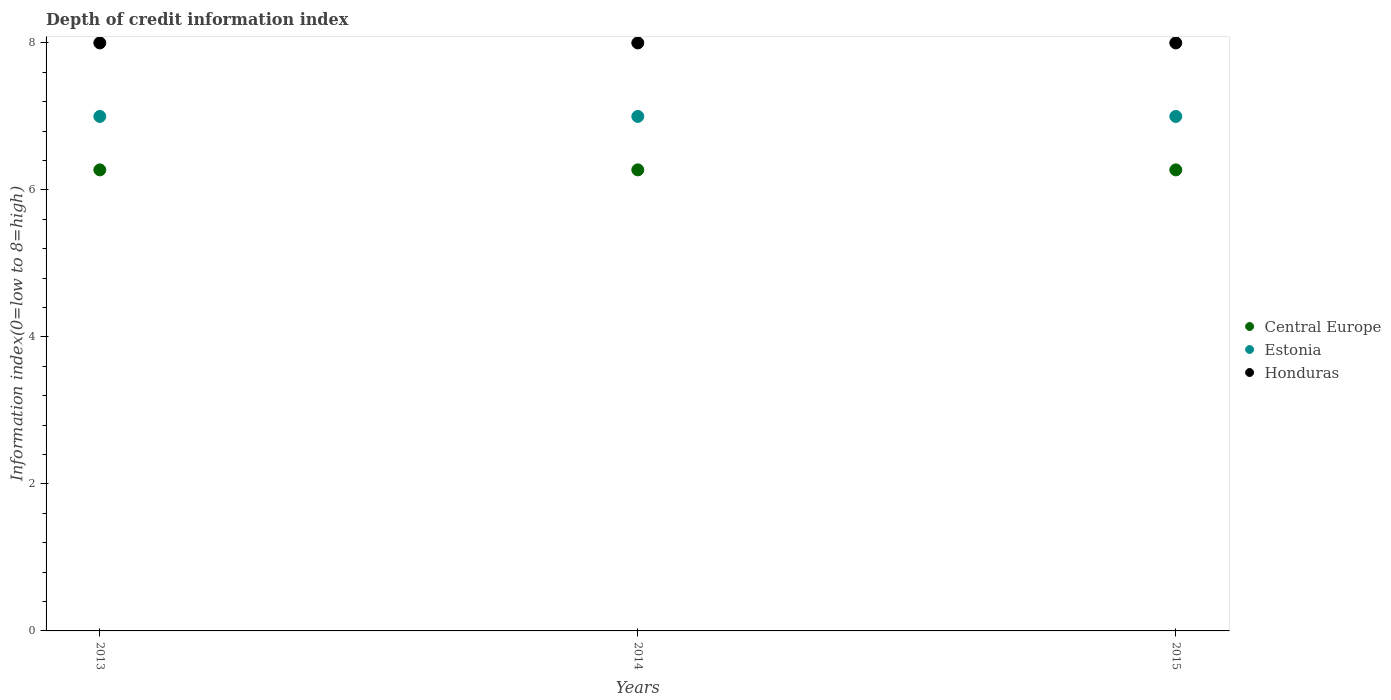How many different coloured dotlines are there?
Provide a succinct answer. 3. What is the information index in Central Europe in 2013?
Make the answer very short. 6.27. Across all years, what is the maximum information index in Estonia?
Make the answer very short. 7. Across all years, what is the minimum information index in Honduras?
Provide a succinct answer. 8. What is the total information index in Honduras in the graph?
Offer a terse response. 24. What is the difference between the information index in Honduras in 2013 and that in 2015?
Provide a succinct answer. 0. What is the difference between the information index in Estonia in 2013 and the information index in Central Europe in 2014?
Offer a very short reply. 0.73. In the year 2013, what is the difference between the information index in Estonia and information index in Honduras?
Provide a succinct answer. -1. What is the ratio of the information index in Estonia in 2013 to that in 2015?
Make the answer very short. 1. Is the difference between the information index in Estonia in 2013 and 2014 greater than the difference between the information index in Honduras in 2013 and 2014?
Your response must be concise. No. What is the difference between the highest and the second highest information index in Central Europe?
Your answer should be very brief. 0. Is the sum of the information index in Estonia in 2013 and 2015 greater than the maximum information index in Honduras across all years?
Your response must be concise. Yes. Is it the case that in every year, the sum of the information index in Estonia and information index in Honduras  is greater than the information index in Central Europe?
Keep it short and to the point. Yes. Does the information index in Estonia monotonically increase over the years?
Make the answer very short. No. What is the difference between two consecutive major ticks on the Y-axis?
Give a very brief answer. 2. Are the values on the major ticks of Y-axis written in scientific E-notation?
Your response must be concise. No. How are the legend labels stacked?
Your answer should be compact. Vertical. What is the title of the graph?
Keep it short and to the point. Depth of credit information index. What is the label or title of the Y-axis?
Your response must be concise. Information index(0=low to 8=high). What is the Information index(0=low to 8=high) in Central Europe in 2013?
Give a very brief answer. 6.27. What is the Information index(0=low to 8=high) in Central Europe in 2014?
Make the answer very short. 6.27. What is the Information index(0=low to 8=high) of Central Europe in 2015?
Make the answer very short. 6.27. What is the Information index(0=low to 8=high) of Honduras in 2015?
Your response must be concise. 8. Across all years, what is the maximum Information index(0=low to 8=high) in Central Europe?
Offer a terse response. 6.27. Across all years, what is the maximum Information index(0=low to 8=high) in Estonia?
Your answer should be compact. 7. Across all years, what is the maximum Information index(0=low to 8=high) of Honduras?
Your answer should be compact. 8. Across all years, what is the minimum Information index(0=low to 8=high) of Central Europe?
Offer a very short reply. 6.27. Across all years, what is the minimum Information index(0=low to 8=high) of Estonia?
Ensure brevity in your answer.  7. What is the total Information index(0=low to 8=high) of Central Europe in the graph?
Keep it short and to the point. 18.82. What is the difference between the Information index(0=low to 8=high) of Central Europe in 2013 and that in 2015?
Give a very brief answer. 0. What is the difference between the Information index(0=low to 8=high) of Central Europe in 2014 and that in 2015?
Your response must be concise. 0. What is the difference between the Information index(0=low to 8=high) of Central Europe in 2013 and the Information index(0=low to 8=high) of Estonia in 2014?
Give a very brief answer. -0.73. What is the difference between the Information index(0=low to 8=high) of Central Europe in 2013 and the Information index(0=low to 8=high) of Honduras in 2014?
Offer a terse response. -1.73. What is the difference between the Information index(0=low to 8=high) of Estonia in 2013 and the Information index(0=low to 8=high) of Honduras in 2014?
Your answer should be very brief. -1. What is the difference between the Information index(0=low to 8=high) of Central Europe in 2013 and the Information index(0=low to 8=high) of Estonia in 2015?
Make the answer very short. -0.73. What is the difference between the Information index(0=low to 8=high) in Central Europe in 2013 and the Information index(0=low to 8=high) in Honduras in 2015?
Provide a succinct answer. -1.73. What is the difference between the Information index(0=low to 8=high) in Central Europe in 2014 and the Information index(0=low to 8=high) in Estonia in 2015?
Give a very brief answer. -0.73. What is the difference between the Information index(0=low to 8=high) in Central Europe in 2014 and the Information index(0=low to 8=high) in Honduras in 2015?
Offer a very short reply. -1.73. What is the average Information index(0=low to 8=high) in Central Europe per year?
Your answer should be compact. 6.27. What is the average Information index(0=low to 8=high) of Estonia per year?
Keep it short and to the point. 7. In the year 2013, what is the difference between the Information index(0=low to 8=high) of Central Europe and Information index(0=low to 8=high) of Estonia?
Provide a succinct answer. -0.73. In the year 2013, what is the difference between the Information index(0=low to 8=high) in Central Europe and Information index(0=low to 8=high) in Honduras?
Ensure brevity in your answer.  -1.73. In the year 2013, what is the difference between the Information index(0=low to 8=high) in Estonia and Information index(0=low to 8=high) in Honduras?
Give a very brief answer. -1. In the year 2014, what is the difference between the Information index(0=low to 8=high) in Central Europe and Information index(0=low to 8=high) in Estonia?
Your answer should be very brief. -0.73. In the year 2014, what is the difference between the Information index(0=low to 8=high) in Central Europe and Information index(0=low to 8=high) in Honduras?
Keep it short and to the point. -1.73. In the year 2015, what is the difference between the Information index(0=low to 8=high) of Central Europe and Information index(0=low to 8=high) of Estonia?
Ensure brevity in your answer.  -0.73. In the year 2015, what is the difference between the Information index(0=low to 8=high) in Central Europe and Information index(0=low to 8=high) in Honduras?
Offer a very short reply. -1.73. In the year 2015, what is the difference between the Information index(0=low to 8=high) of Estonia and Information index(0=low to 8=high) of Honduras?
Keep it short and to the point. -1. What is the ratio of the Information index(0=low to 8=high) in Central Europe in 2013 to that in 2014?
Your answer should be compact. 1. What is the ratio of the Information index(0=low to 8=high) of Honduras in 2013 to that in 2014?
Your answer should be compact. 1. What is the ratio of the Information index(0=low to 8=high) in Central Europe in 2014 to that in 2015?
Offer a terse response. 1. What is the ratio of the Information index(0=low to 8=high) of Honduras in 2014 to that in 2015?
Provide a short and direct response. 1. What is the difference between the highest and the second highest Information index(0=low to 8=high) of Central Europe?
Provide a short and direct response. 0. What is the difference between the highest and the lowest Information index(0=low to 8=high) of Estonia?
Provide a short and direct response. 0. 